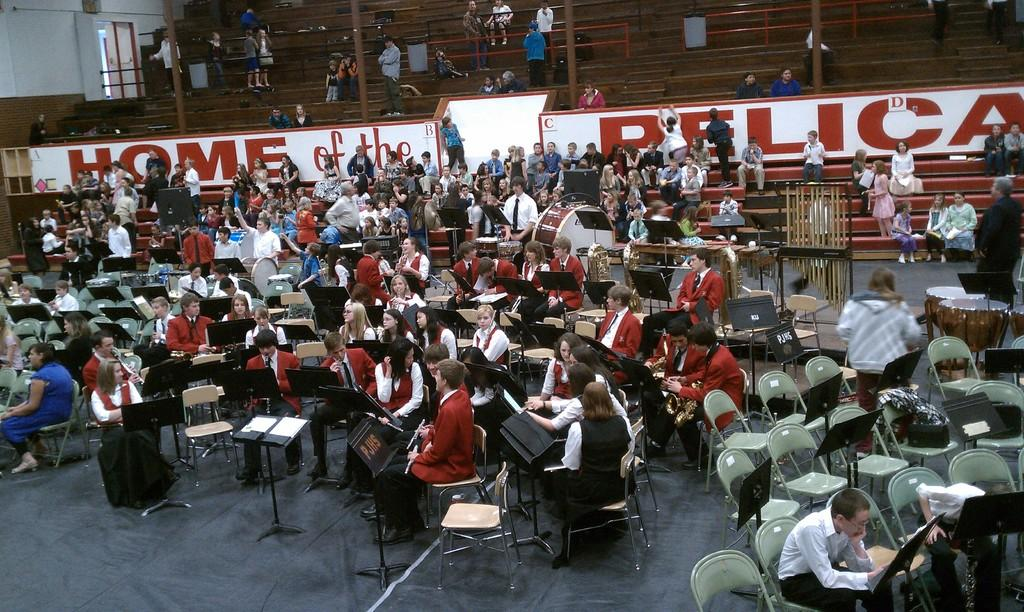What is the composition of the group in the image? There is a group of boys and girls in the image. How are the group members positioned in the image? The group is sitting on chairs. Where is the image taken? The location is a stadium ground. What activity is the group engaged in? The purpose is a music class. What can be seen in the background of the image? There are stadium seats visible in the background. What type of quill is the girl using to write a statement in the image? There is no girl using a quill or writing a statement in the image. 